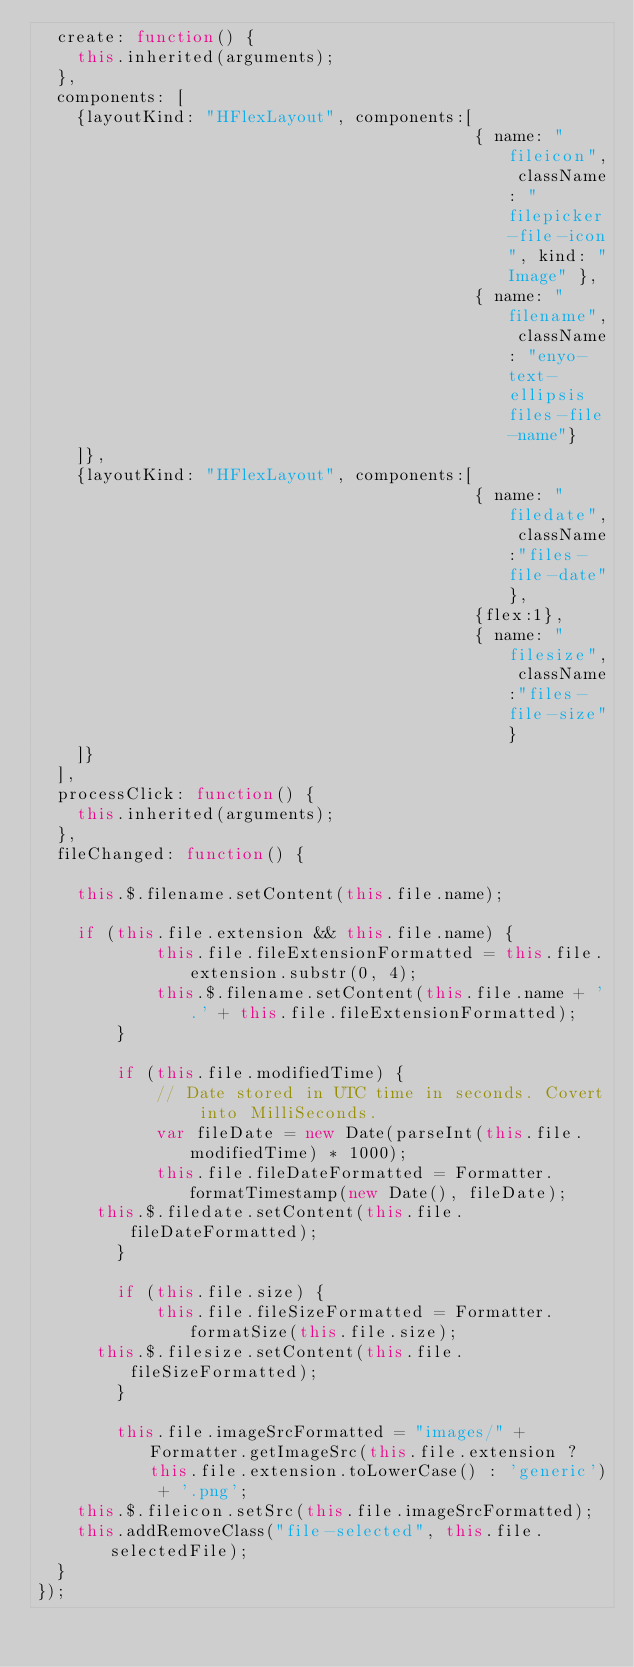Convert code to text. <code><loc_0><loc_0><loc_500><loc_500><_JavaScript_>	create: function() {
		this.inherited(arguments);
	},
	components: [
		{layoutKind: "HFlexLayout", components:[
		                                        { name: "fileicon", className: "filepicker-file-icon", kind: "Image" },
		                                        { name: "filename", className: "enyo-text-ellipsis files-file-name"}
		]},
		{layoutKind: "HFlexLayout", components:[                                       
		                                        { name: "filedate", className:"files-file-date"},
		                                        {flex:1},
		                                        { name: "filesize", className:"files-file-size"}
		]}
	],
	processClick: function() {
		this.inherited(arguments);
	},
	fileChanged: function() {
		
		this.$.filename.setContent(this.file.name);
        
		if (this.file.extension && this.file.name) {
            this.file.fileExtensionFormatted = this.file.extension.substr(0, 4);
            this.$.filename.setContent(this.file.name + '.' + this.file.fileExtensionFormatted);
        }
		
        if (this.file.modifiedTime) {
            // Date stored in UTC time in seconds. Covert into MilliSeconds.
            var fileDate = new Date(parseInt(this.file.modifiedTime) * 1000);
            this.file.fileDateFormatted = Formatter.formatTimestamp(new Date(), fileDate);
			this.$.filedate.setContent(this.file.fileDateFormatted);
        }
        
       	if (this.file.size) {
            this.file.fileSizeFormatted = Formatter.formatSize(this.file.size);
			this.$.filesize.setContent(this.file.fileSizeFormatted);
        }
       	
       	this.file.imageSrcFormatted = "images/" + Formatter.getImageSrc(this.file.extension ? this.file.extension.toLowerCase() : 'generic') + '.png';
		this.$.fileicon.setSrc(this.file.imageSrcFormatted);
		this.addRemoveClass("file-selected", this.file.selectedFile);
	}
});</code> 